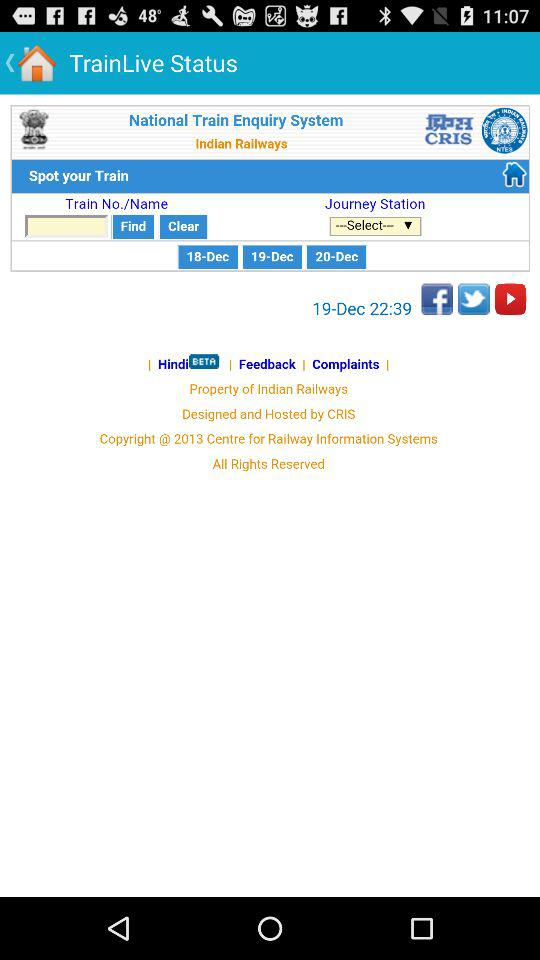What is the time? The time is 22:39. 